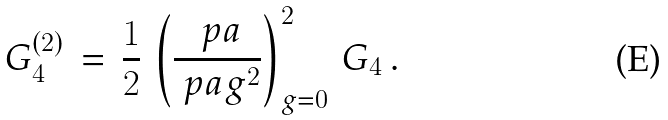Convert formula to latex. <formula><loc_0><loc_0><loc_500><loc_500>G _ { 4 } ^ { ( 2 ) } \, = \, \frac { 1 } { 2 } \, \left ( \frac { \ p a } { \ p a g ^ { 2 } } \right ) _ { g = 0 } ^ { 2 } \, G _ { 4 } \, .</formula> 